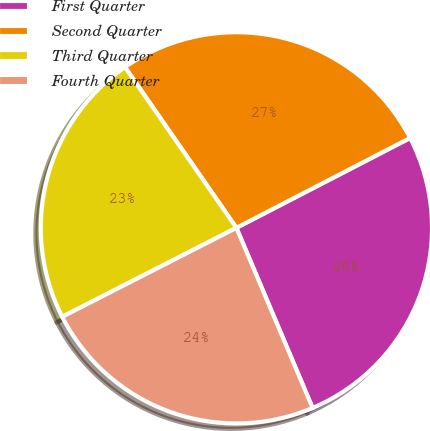Convert chart to OTSL. <chart><loc_0><loc_0><loc_500><loc_500><pie_chart><fcel>First Quarter<fcel>Second Quarter<fcel>Third Quarter<fcel>Fourth Quarter<nl><fcel>26.23%<fcel>27.05%<fcel>22.87%<fcel>23.85%<nl></chart> 